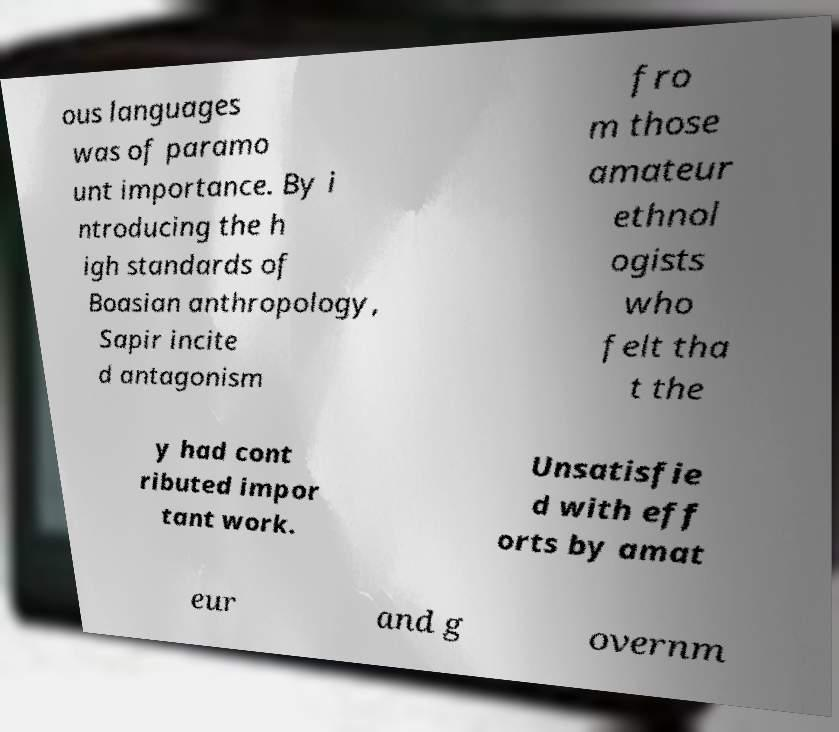There's text embedded in this image that I need extracted. Can you transcribe it verbatim? ous languages was of paramo unt importance. By i ntroducing the h igh standards of Boasian anthropology, Sapir incite d antagonism fro m those amateur ethnol ogists who felt tha t the y had cont ributed impor tant work. Unsatisfie d with eff orts by amat eur and g overnm 